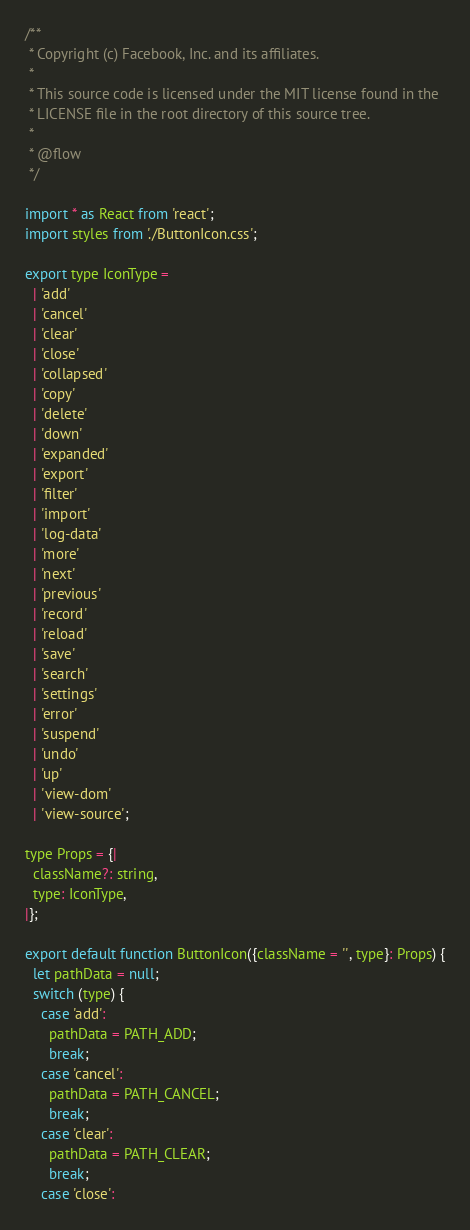<code> <loc_0><loc_0><loc_500><loc_500><_JavaScript_>/**
 * Copyright (c) Facebook, Inc. and its affiliates.
 *
 * This source code is licensed under the MIT license found in the
 * LICENSE file in the root directory of this source tree.
 *
 * @flow
 */

import * as React from 'react';
import styles from './ButtonIcon.css';

export type IconType =
  | 'add'
  | 'cancel'
  | 'clear'
  | 'close'
  | 'collapsed'
  | 'copy'
  | 'delete'
  | 'down'
  | 'expanded'
  | 'export'
  | 'filter'
  | 'import'
  | 'log-data'
  | 'more'
  | 'next'
  | 'previous'
  | 'record'
  | 'reload'
  | 'save'
  | 'search'
  | 'settings'
  | 'error'
  | 'suspend'
  | 'undo'
  | 'up'
  | 'view-dom'
  | 'view-source';

type Props = {|
  className?: string,
  type: IconType,
|};

export default function ButtonIcon({className = '', type}: Props) {
  let pathData = null;
  switch (type) {
    case 'add':
      pathData = PATH_ADD;
      break;
    case 'cancel':
      pathData = PATH_CANCEL;
      break;
    case 'clear':
      pathData = PATH_CLEAR;
      break;
    case 'close':</code> 